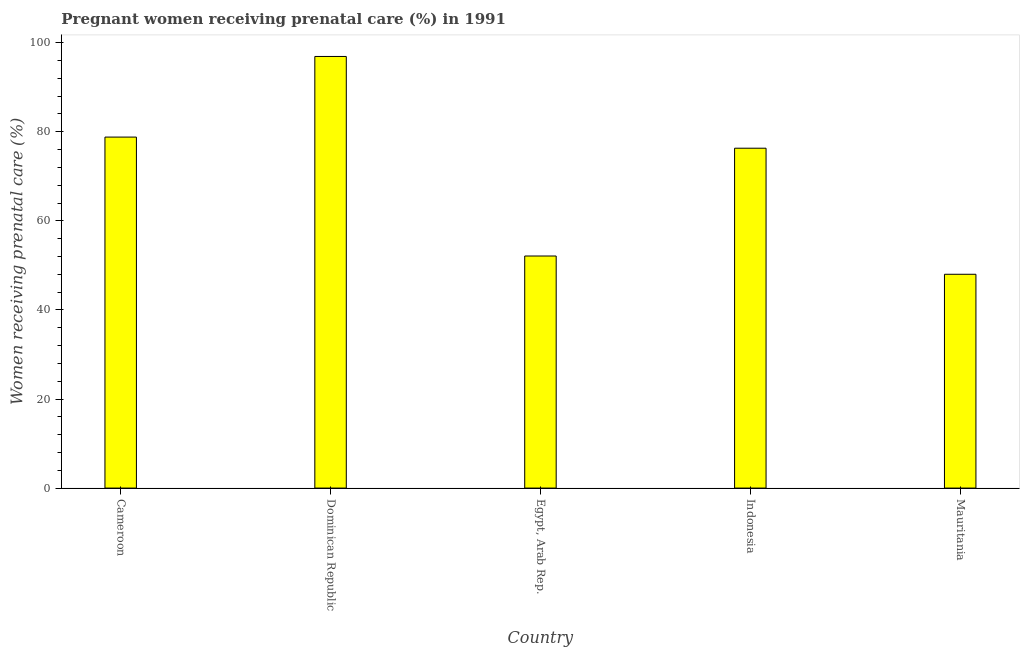What is the title of the graph?
Your answer should be compact. Pregnant women receiving prenatal care (%) in 1991. What is the label or title of the Y-axis?
Provide a succinct answer. Women receiving prenatal care (%). What is the percentage of pregnant women receiving prenatal care in Cameroon?
Provide a succinct answer. 78.8. Across all countries, what is the maximum percentage of pregnant women receiving prenatal care?
Your answer should be compact. 96.9. In which country was the percentage of pregnant women receiving prenatal care maximum?
Your answer should be compact. Dominican Republic. In which country was the percentage of pregnant women receiving prenatal care minimum?
Your answer should be compact. Mauritania. What is the sum of the percentage of pregnant women receiving prenatal care?
Your answer should be compact. 352.1. What is the difference between the percentage of pregnant women receiving prenatal care in Indonesia and Mauritania?
Give a very brief answer. 28.3. What is the average percentage of pregnant women receiving prenatal care per country?
Your answer should be compact. 70.42. What is the median percentage of pregnant women receiving prenatal care?
Ensure brevity in your answer.  76.3. What is the ratio of the percentage of pregnant women receiving prenatal care in Indonesia to that in Mauritania?
Ensure brevity in your answer.  1.59. Is the percentage of pregnant women receiving prenatal care in Indonesia less than that in Mauritania?
Your answer should be very brief. No. What is the difference between the highest and the lowest percentage of pregnant women receiving prenatal care?
Your answer should be compact. 48.9. In how many countries, is the percentage of pregnant women receiving prenatal care greater than the average percentage of pregnant women receiving prenatal care taken over all countries?
Provide a short and direct response. 3. What is the Women receiving prenatal care (%) of Cameroon?
Provide a short and direct response. 78.8. What is the Women receiving prenatal care (%) in Dominican Republic?
Provide a short and direct response. 96.9. What is the Women receiving prenatal care (%) of Egypt, Arab Rep.?
Your response must be concise. 52.1. What is the Women receiving prenatal care (%) of Indonesia?
Your answer should be very brief. 76.3. What is the difference between the Women receiving prenatal care (%) in Cameroon and Dominican Republic?
Provide a short and direct response. -18.1. What is the difference between the Women receiving prenatal care (%) in Cameroon and Egypt, Arab Rep.?
Provide a succinct answer. 26.7. What is the difference between the Women receiving prenatal care (%) in Cameroon and Indonesia?
Give a very brief answer. 2.5. What is the difference between the Women receiving prenatal care (%) in Cameroon and Mauritania?
Offer a terse response. 30.8. What is the difference between the Women receiving prenatal care (%) in Dominican Republic and Egypt, Arab Rep.?
Your answer should be compact. 44.8. What is the difference between the Women receiving prenatal care (%) in Dominican Republic and Indonesia?
Make the answer very short. 20.6. What is the difference between the Women receiving prenatal care (%) in Dominican Republic and Mauritania?
Offer a terse response. 48.9. What is the difference between the Women receiving prenatal care (%) in Egypt, Arab Rep. and Indonesia?
Ensure brevity in your answer.  -24.2. What is the difference between the Women receiving prenatal care (%) in Indonesia and Mauritania?
Make the answer very short. 28.3. What is the ratio of the Women receiving prenatal care (%) in Cameroon to that in Dominican Republic?
Offer a very short reply. 0.81. What is the ratio of the Women receiving prenatal care (%) in Cameroon to that in Egypt, Arab Rep.?
Your answer should be very brief. 1.51. What is the ratio of the Women receiving prenatal care (%) in Cameroon to that in Indonesia?
Give a very brief answer. 1.03. What is the ratio of the Women receiving prenatal care (%) in Cameroon to that in Mauritania?
Keep it short and to the point. 1.64. What is the ratio of the Women receiving prenatal care (%) in Dominican Republic to that in Egypt, Arab Rep.?
Make the answer very short. 1.86. What is the ratio of the Women receiving prenatal care (%) in Dominican Republic to that in Indonesia?
Ensure brevity in your answer.  1.27. What is the ratio of the Women receiving prenatal care (%) in Dominican Republic to that in Mauritania?
Your response must be concise. 2.02. What is the ratio of the Women receiving prenatal care (%) in Egypt, Arab Rep. to that in Indonesia?
Keep it short and to the point. 0.68. What is the ratio of the Women receiving prenatal care (%) in Egypt, Arab Rep. to that in Mauritania?
Keep it short and to the point. 1.08. What is the ratio of the Women receiving prenatal care (%) in Indonesia to that in Mauritania?
Your response must be concise. 1.59. 